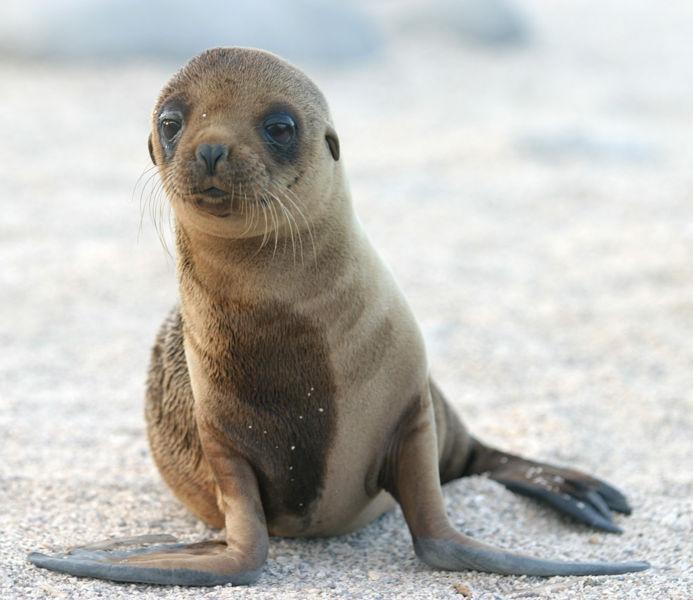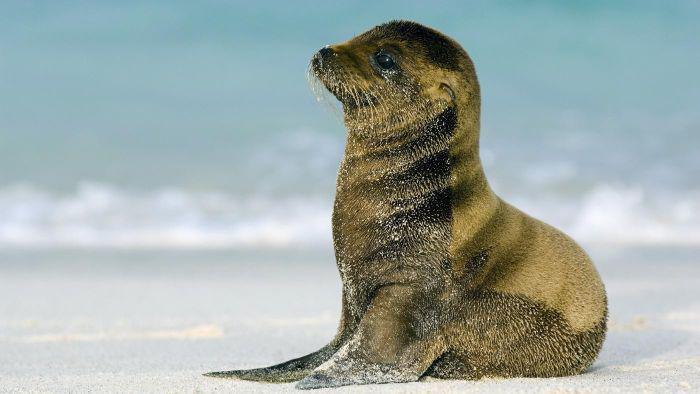The first image is the image on the left, the second image is the image on the right. Considering the images on both sides, is "the baby seal on the right is lying down." valid? Answer yes or no. No. 